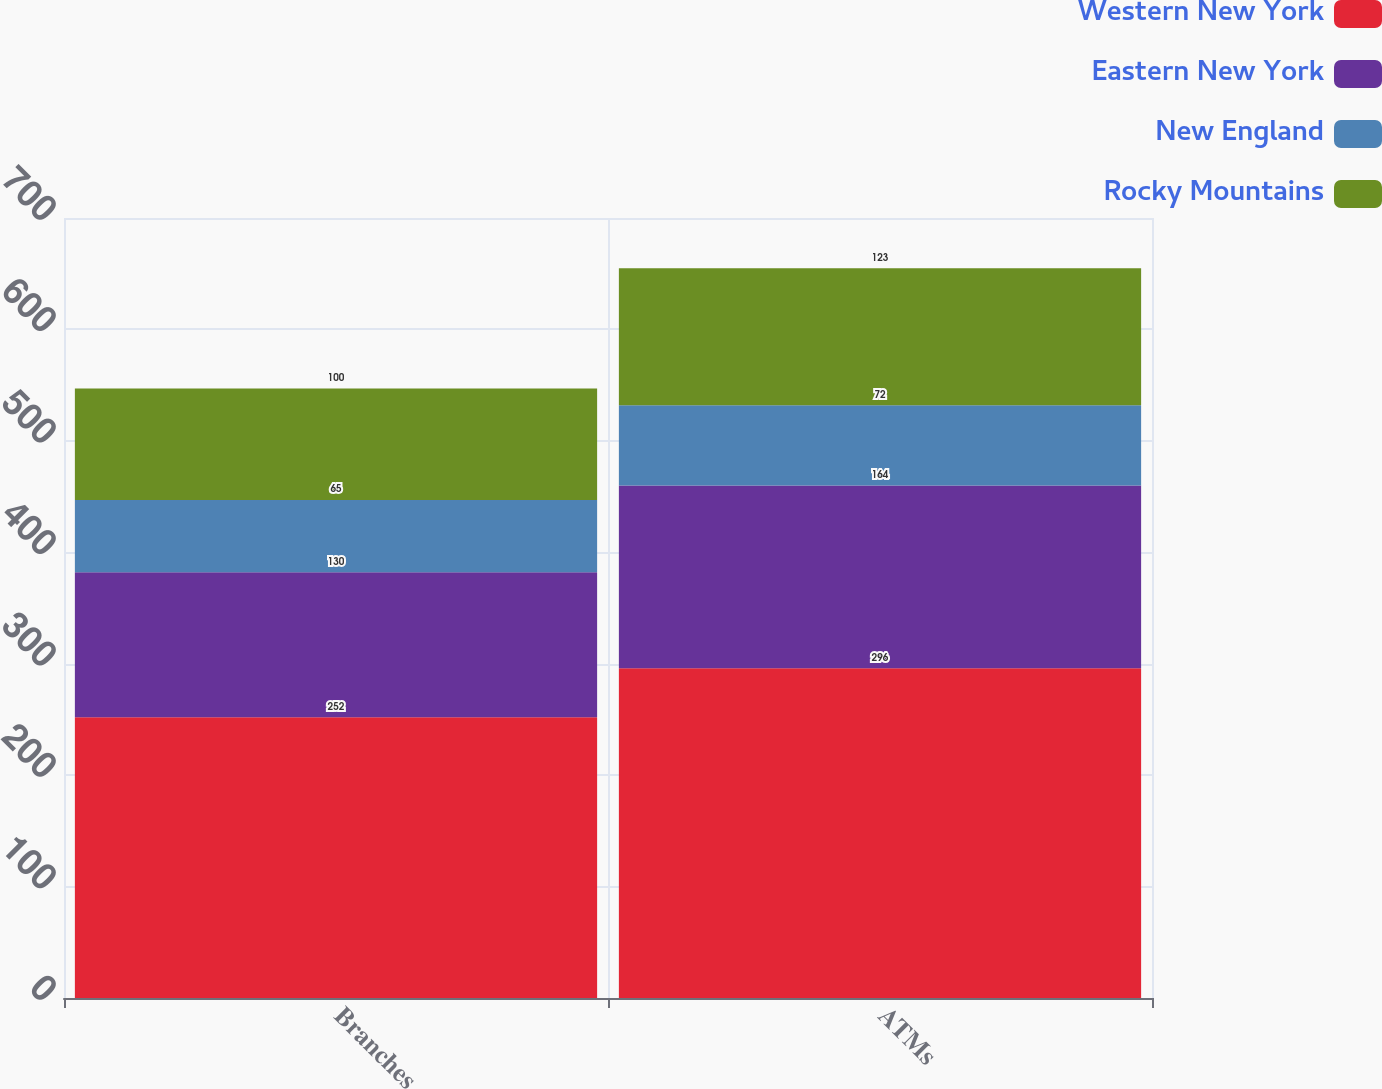<chart> <loc_0><loc_0><loc_500><loc_500><stacked_bar_chart><ecel><fcel>Branches<fcel>ATMs<nl><fcel>Western New York<fcel>252<fcel>296<nl><fcel>Eastern New York<fcel>130<fcel>164<nl><fcel>New England<fcel>65<fcel>72<nl><fcel>Rocky Mountains<fcel>100<fcel>123<nl></chart> 